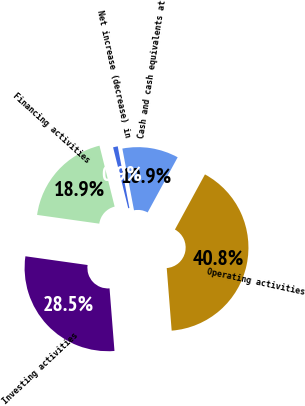Convert chart to OTSL. <chart><loc_0><loc_0><loc_500><loc_500><pie_chart><fcel>Cash and cash equivalents at<fcel>Operating activities<fcel>Investing activities<fcel>Financing activities<fcel>Net increase (decrease) in<nl><fcel>10.91%<fcel>40.81%<fcel>28.48%<fcel>18.89%<fcel>0.91%<nl></chart> 